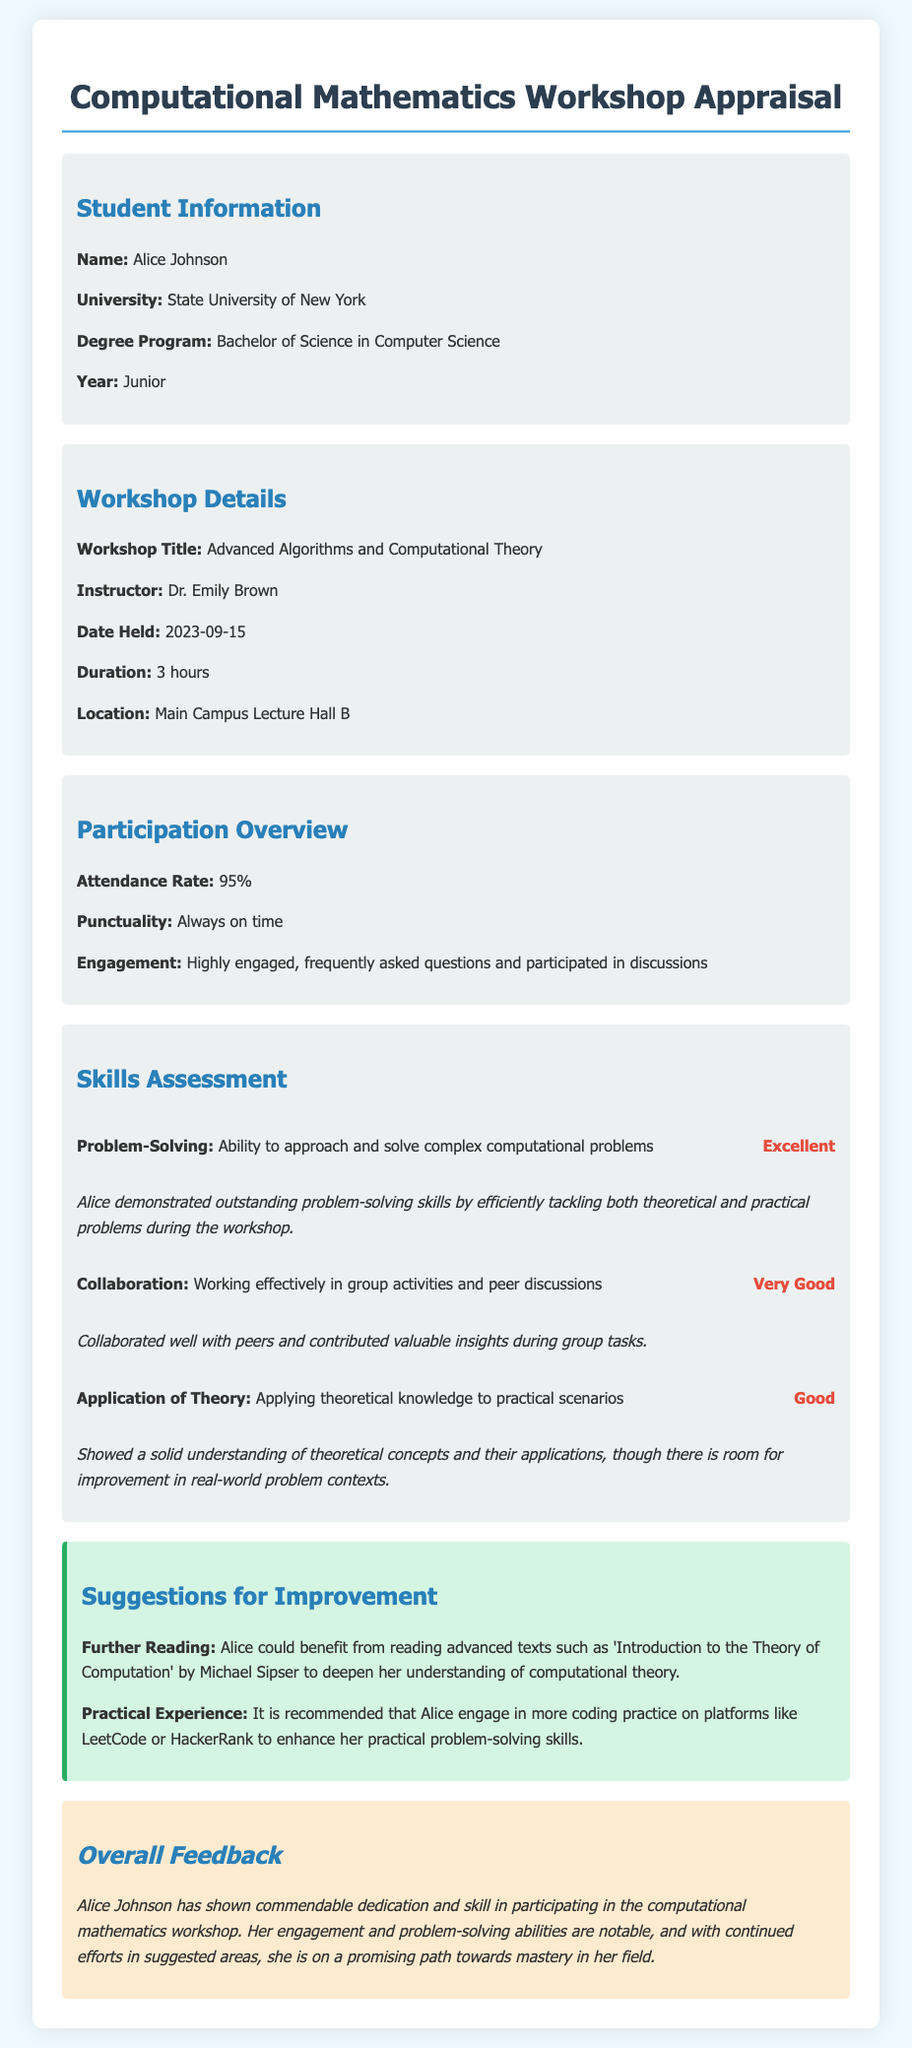What is the name of the student? The student's name is provided in the document under Student Information.
Answer: Alice Johnson What is the date the workshop was held? The date of the workshop is mentioned in the Workshop Details section.
Answer: 2023-09-15 What is the attendance rate of Alice? The attendance rate is specified in the Participation Overview section.
Answer: 95% What is the rating for Alice's problem-solving skills? The rating for problem-solving skills can be found in the Skills Assessment section.
Answer: Excellent What is one suggestion for improvement provided in the document? Suggestions for improvement are listed in the Suggestions for Improvement section.
Answer: Further Reading How long was the workshop? The duration of the workshop is mentioned in the Workshop Details section.
Answer: 3 hours Who is the instructor of the workshop? The instructor's name is provided in the Workshop Details section.
Answer: Dr. Emily Brown How engaged was Alice during the workshop? Engagement is assessed in the Participation Overview section.
Answer: Highly engaged What is the degree program of Alice? The degree program can be found in the Student Information section.
Answer: Bachelor of Science in Computer Science 